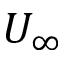<formula> <loc_0><loc_0><loc_500><loc_500>U _ { \infty }</formula> 